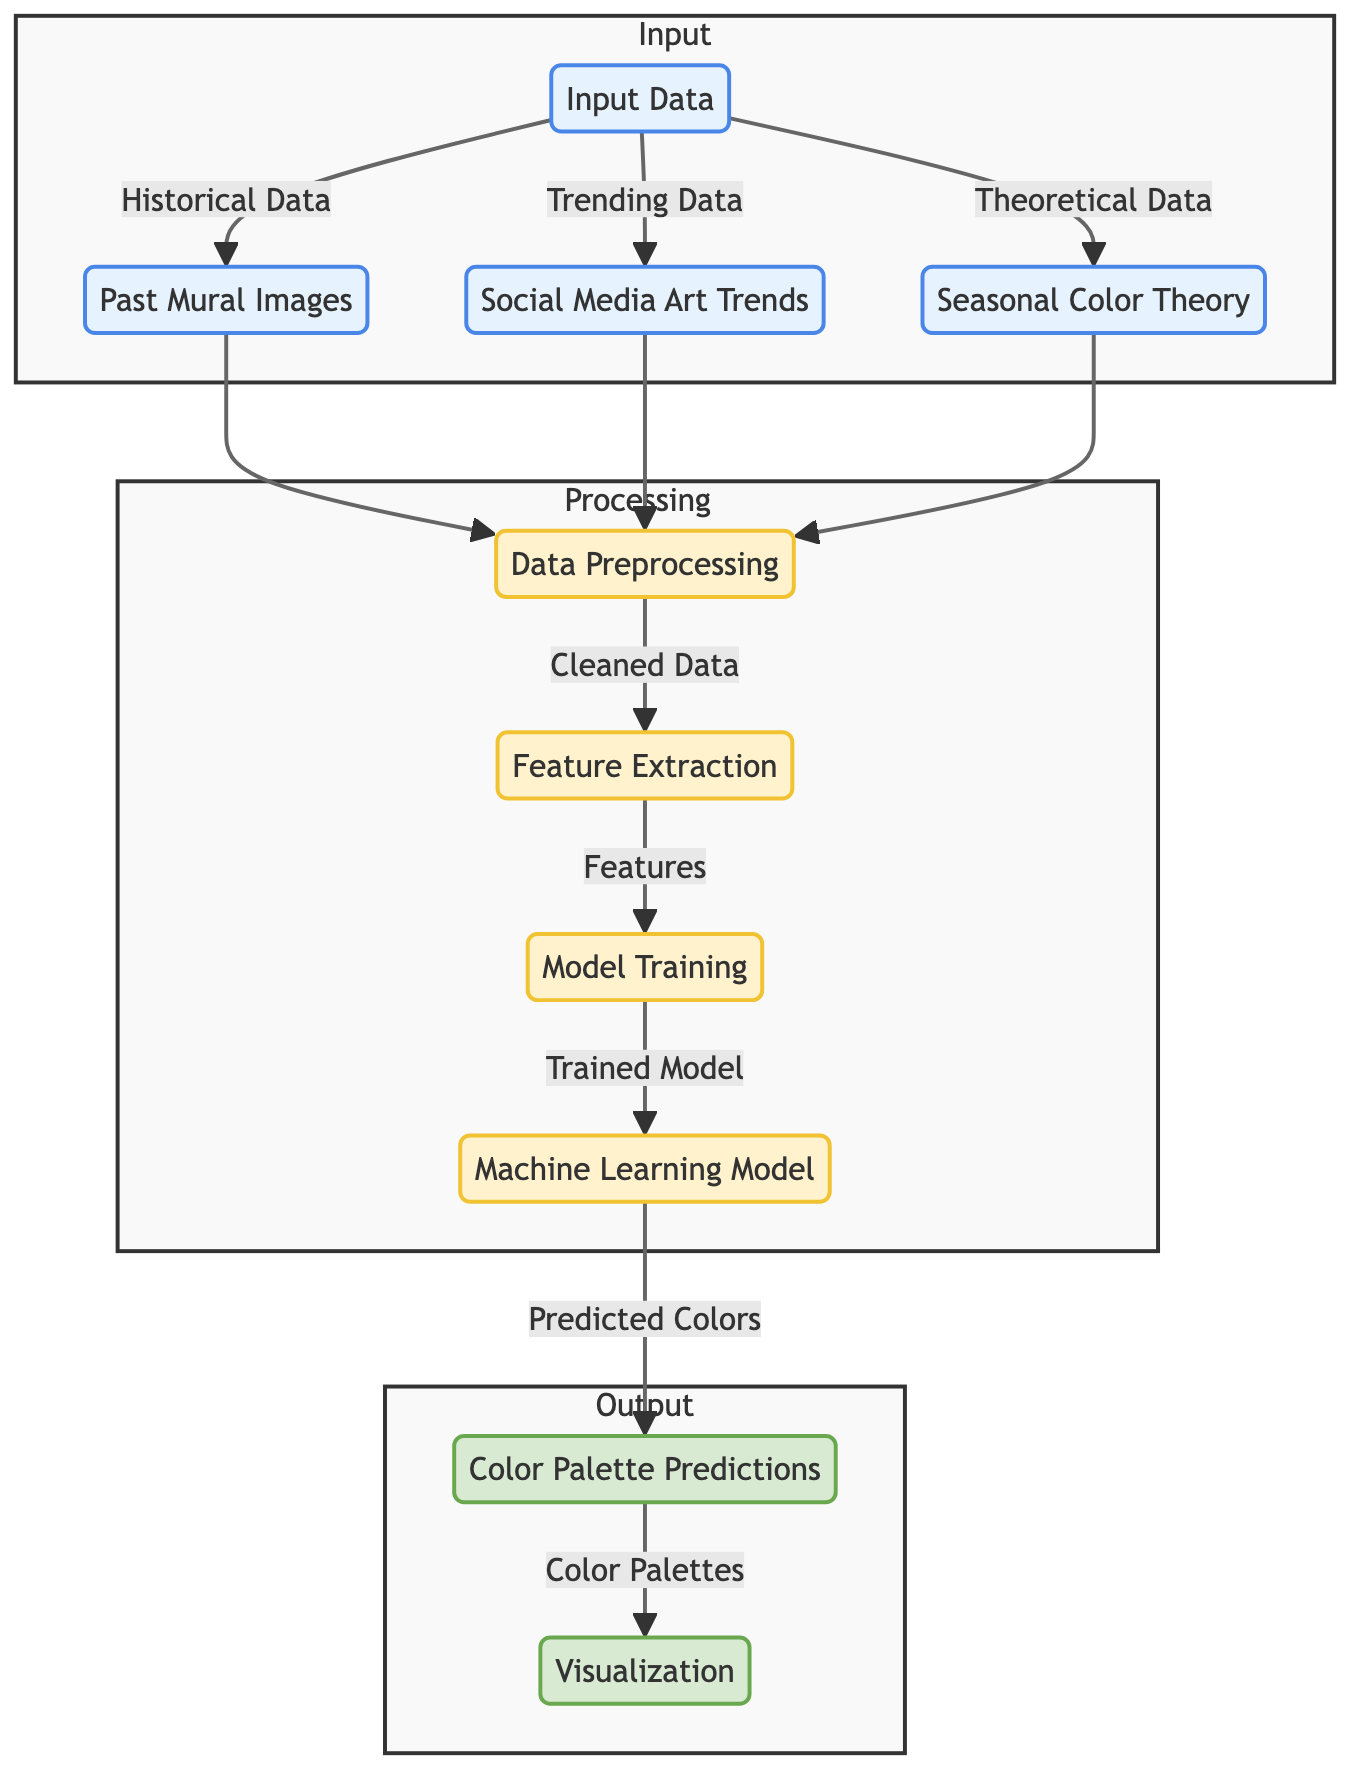What types of input data are used in the model? The diagram highlights three specific types of input data: past mural images, social media art trends, and seasonal color theory. These are directly linked to the input_data node, which signifies their role in the model's training process.
Answer: past mural images, social media art trends, seasonal color theory How many nodes are in the Input section? The Input section of the diagram contains four distinct nodes: input_data, past_mural_images, social_media_trends, and seasonal_color_theory. Counting these nodes gives the total number of entities in that section.
Answer: 4 What is the output of the machine learning model? The output of the machine learning model is specifically indicated by the 'color_palette_predictions' node, which suggests the model's primary output after processing its learned patterns from the input.
Answer: Color Palette Predictions What process follows data preprocessing? According to the diagram, the flow progresses from data preprocessing to feature extraction, indicating that after cleansing the input data, features are extracted for model training.
Answer: Feature Extraction What connects seasonal color theory to the data preprocessing step? The 'seasonal_color_theory' node connects to the 'data_preprocessing' node, signifying that its data is utilized in the preprocessing step, integral for refining the inputs before they are extracted as features.
Answer: Data Preprocessing Which step directly leads to model training? The step that directly leads to model training is feature extraction. The diagram illustrates this by showing an arrow from the feature_extraction node to the model_training node, indicating that extracted features are needed for training the model.
Answer: Model Training How many output nodes exist in the diagram? The output section comprises two nodes: color_palette_predictions and visualization. By counting these, we can determine the total number of output entities depicted in the diagram.
Answer: 2 Which node indicates that the model has been trained? The 'machine_learning_model' node represents that the model has been trained, as denoted by the edge coming from the model_training node leading to this node, signifying completion of the training process.
Answer: Machine Learning Model What is the purpose of the visualization node? The visualization node illustrates the final result of the color palettes predicted by the model, as indicated by the flow from 'color_palette_predictions' to 'visualization'. This shows the outcomes are visualized for easier interpretation.
Answer: Visualization 